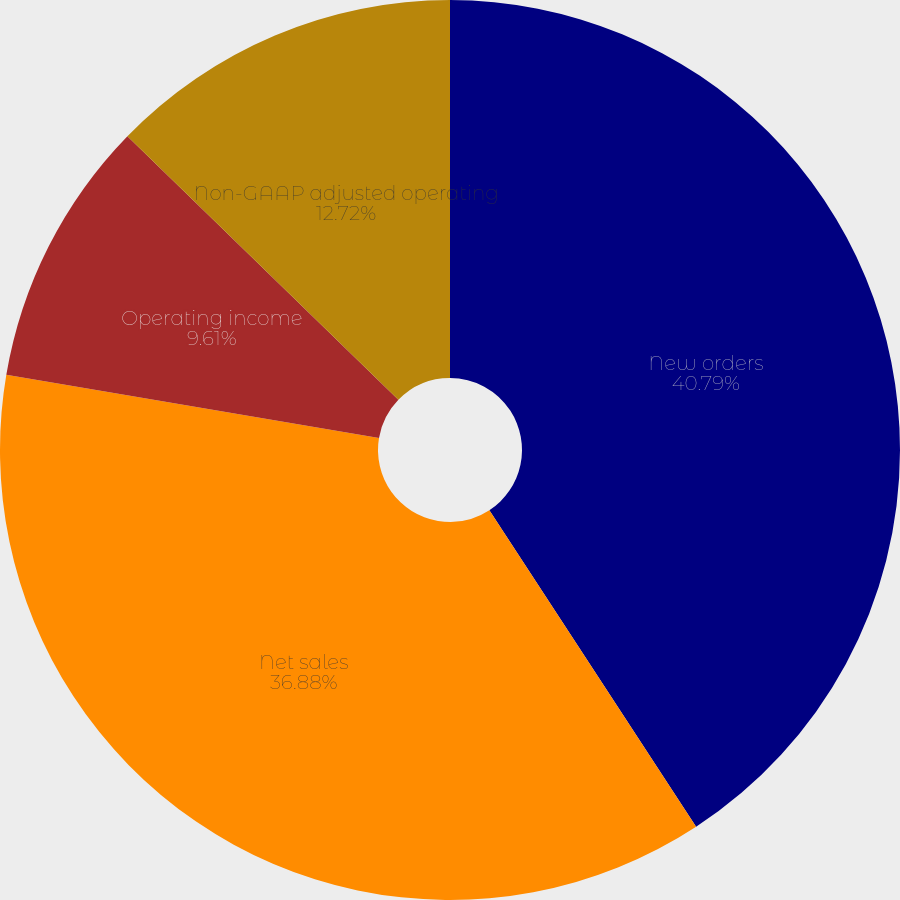Convert chart to OTSL. <chart><loc_0><loc_0><loc_500><loc_500><pie_chart><fcel>New orders<fcel>Net sales<fcel>Operating income<fcel>Non-GAAP adjusted operating<nl><fcel>40.79%<fcel>36.88%<fcel>9.61%<fcel>12.72%<nl></chart> 